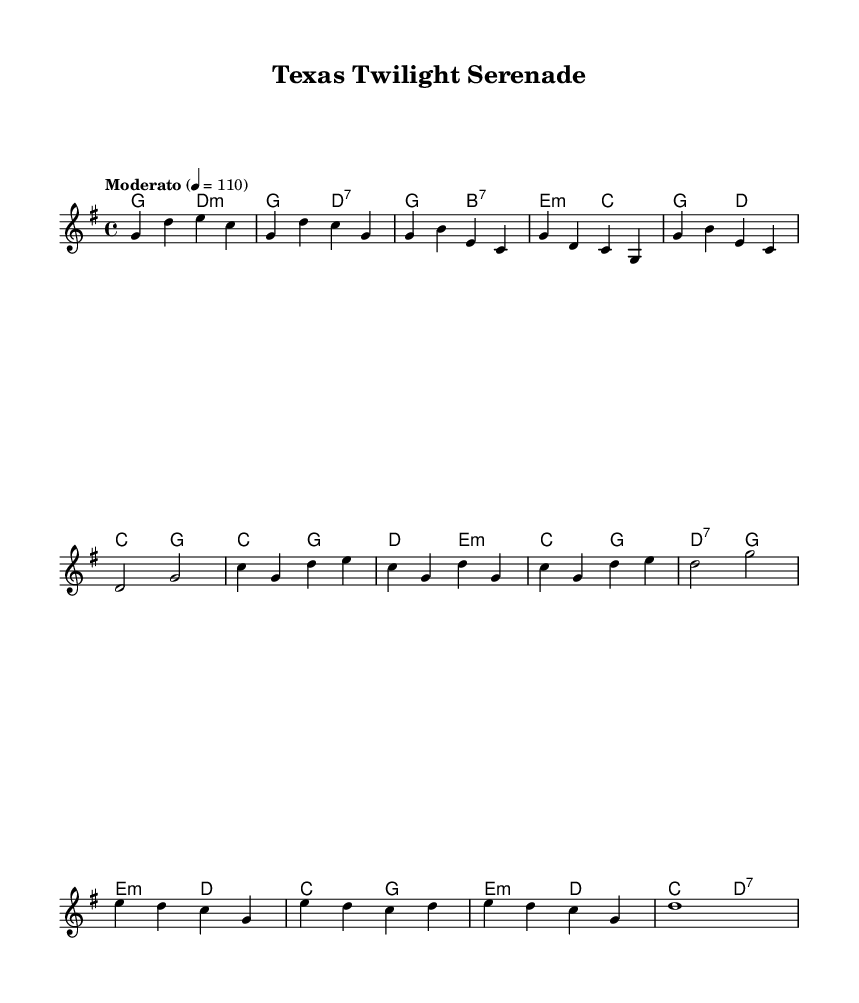What is the key signature of this music? The key signature is G major, which has one sharp (F#).
Answer: G major What is the time signature of this piece? The time signature is 4/4, indicating four beats per measure.
Answer: 4/4 What is the tempo marking of the music? The tempo marking indicates "Moderato," which typically suggests a moderate speed.
Answer: Moderato How many measures are there in the music? By counting the sections and notes in the melody and harmonies, there are 16 total measures.
Answer: 16 What is the starting chord of the piece? The piece begins with the chord G major, as indicated in the harmonies section.
Answer: G major What is the primary genre influence evident in this music? The music exhibits Jazz-country fusion, reflecting elements from both styles, particularly in the rhythm and chord progressions.
Answer: Jazz-country fusion What is the last note of the melody? The last note of the melody is a G, which is aligned with the melody's concluding bar.
Answer: G 